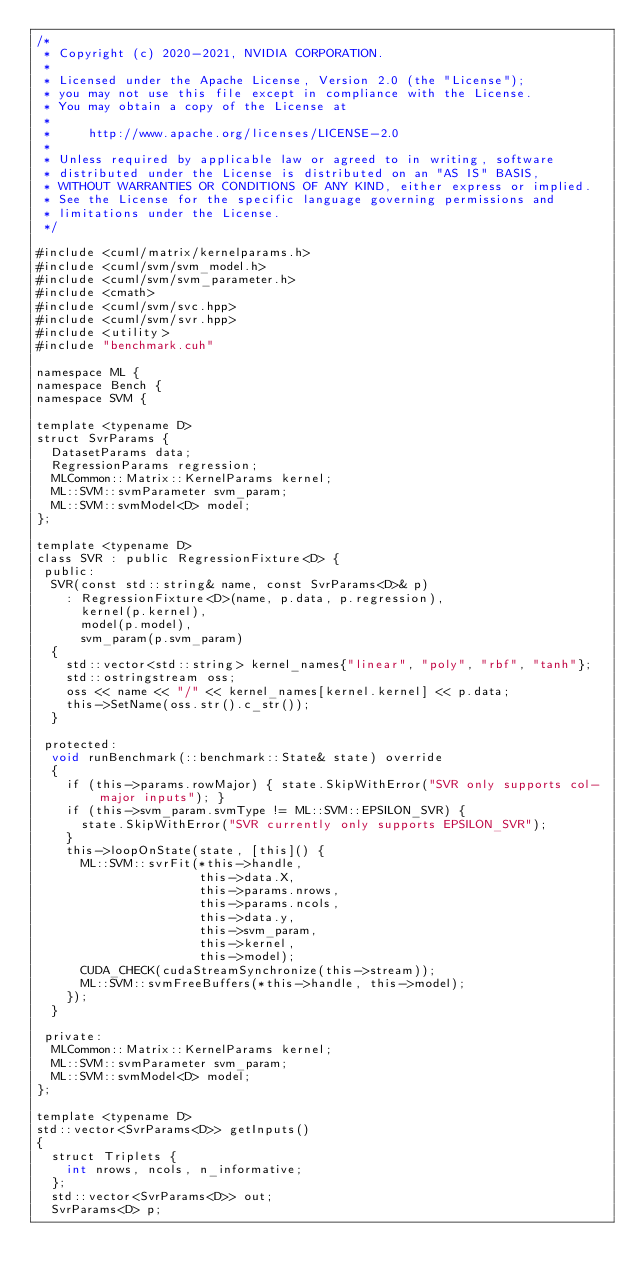<code> <loc_0><loc_0><loc_500><loc_500><_Cuda_>/*
 * Copyright (c) 2020-2021, NVIDIA CORPORATION.
 *
 * Licensed under the Apache License, Version 2.0 (the "License");
 * you may not use this file except in compliance with the License.
 * You may obtain a copy of the License at
 *
 *     http://www.apache.org/licenses/LICENSE-2.0
 *
 * Unless required by applicable law or agreed to in writing, software
 * distributed under the License is distributed on an "AS IS" BASIS,
 * WITHOUT WARRANTIES OR CONDITIONS OF ANY KIND, either express or implied.
 * See the License for the specific language governing permissions and
 * limitations under the License.
 */

#include <cuml/matrix/kernelparams.h>
#include <cuml/svm/svm_model.h>
#include <cuml/svm/svm_parameter.h>
#include <cmath>
#include <cuml/svm/svc.hpp>
#include <cuml/svm/svr.hpp>
#include <utility>
#include "benchmark.cuh"

namespace ML {
namespace Bench {
namespace SVM {

template <typename D>
struct SvrParams {
  DatasetParams data;
  RegressionParams regression;
  MLCommon::Matrix::KernelParams kernel;
  ML::SVM::svmParameter svm_param;
  ML::SVM::svmModel<D> model;
};

template <typename D>
class SVR : public RegressionFixture<D> {
 public:
  SVR(const std::string& name, const SvrParams<D>& p)
    : RegressionFixture<D>(name, p.data, p.regression),
      kernel(p.kernel),
      model(p.model),
      svm_param(p.svm_param)
  {
    std::vector<std::string> kernel_names{"linear", "poly", "rbf", "tanh"};
    std::ostringstream oss;
    oss << name << "/" << kernel_names[kernel.kernel] << p.data;
    this->SetName(oss.str().c_str());
  }

 protected:
  void runBenchmark(::benchmark::State& state) override
  {
    if (this->params.rowMajor) { state.SkipWithError("SVR only supports col-major inputs"); }
    if (this->svm_param.svmType != ML::SVM::EPSILON_SVR) {
      state.SkipWithError("SVR currently only supports EPSILON_SVR");
    }
    this->loopOnState(state, [this]() {
      ML::SVM::svrFit(*this->handle,
                      this->data.X,
                      this->params.nrows,
                      this->params.ncols,
                      this->data.y,
                      this->svm_param,
                      this->kernel,
                      this->model);
      CUDA_CHECK(cudaStreamSynchronize(this->stream));
      ML::SVM::svmFreeBuffers(*this->handle, this->model);
    });
  }

 private:
  MLCommon::Matrix::KernelParams kernel;
  ML::SVM::svmParameter svm_param;
  ML::SVM::svmModel<D> model;
};

template <typename D>
std::vector<SvrParams<D>> getInputs()
{
  struct Triplets {
    int nrows, ncols, n_informative;
  };
  std::vector<SvrParams<D>> out;
  SvrParams<D> p;
</code> 